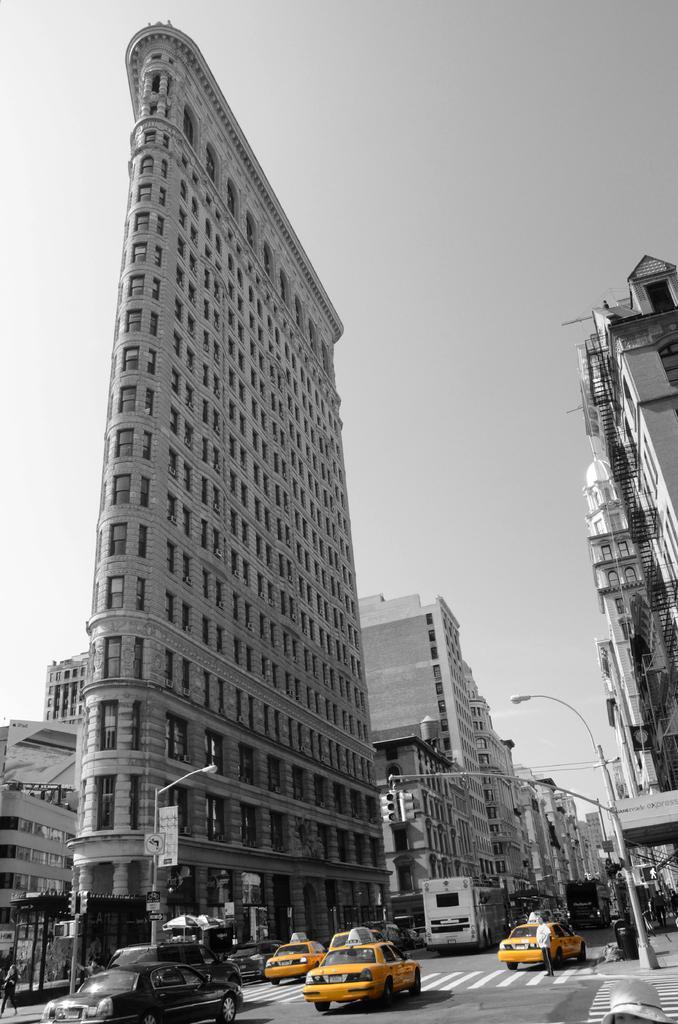How would you summarize this image in a sentence or two? In the image there are many cars going on the road with buildings on either side of it and above its sky, this is a black and white picture. 